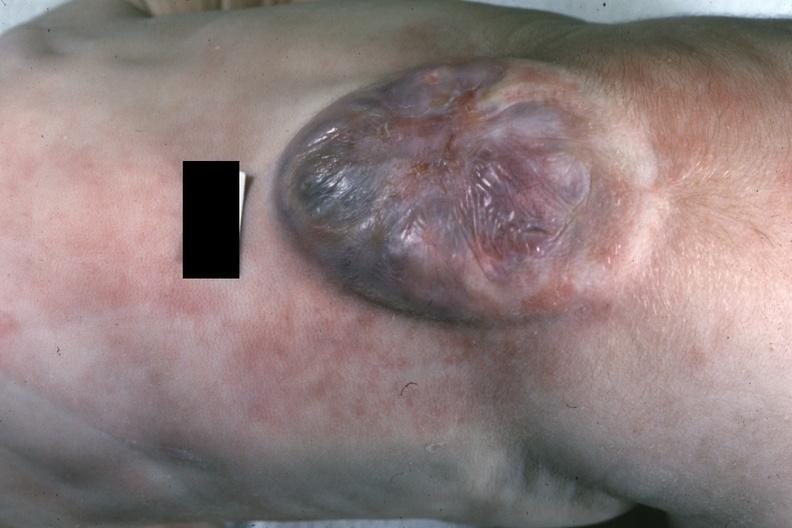s lymphangiomatosis generalized present?
Answer the question using a single word or phrase. No 